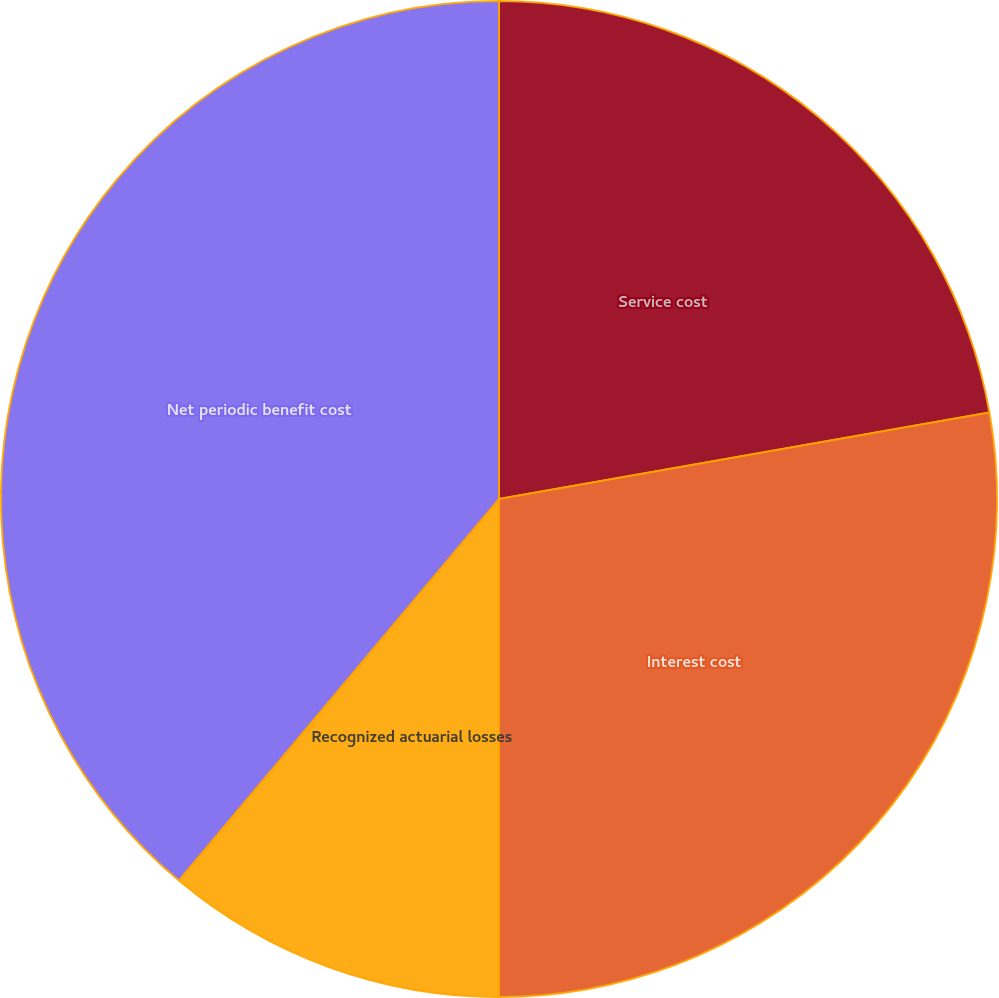Convert chart to OTSL. <chart><loc_0><loc_0><loc_500><loc_500><pie_chart><fcel>Service cost<fcel>Interest cost<fcel>Recognized actuarial losses<fcel>Net periodic benefit cost<nl><fcel>22.22%<fcel>27.78%<fcel>11.11%<fcel>38.89%<nl></chart> 